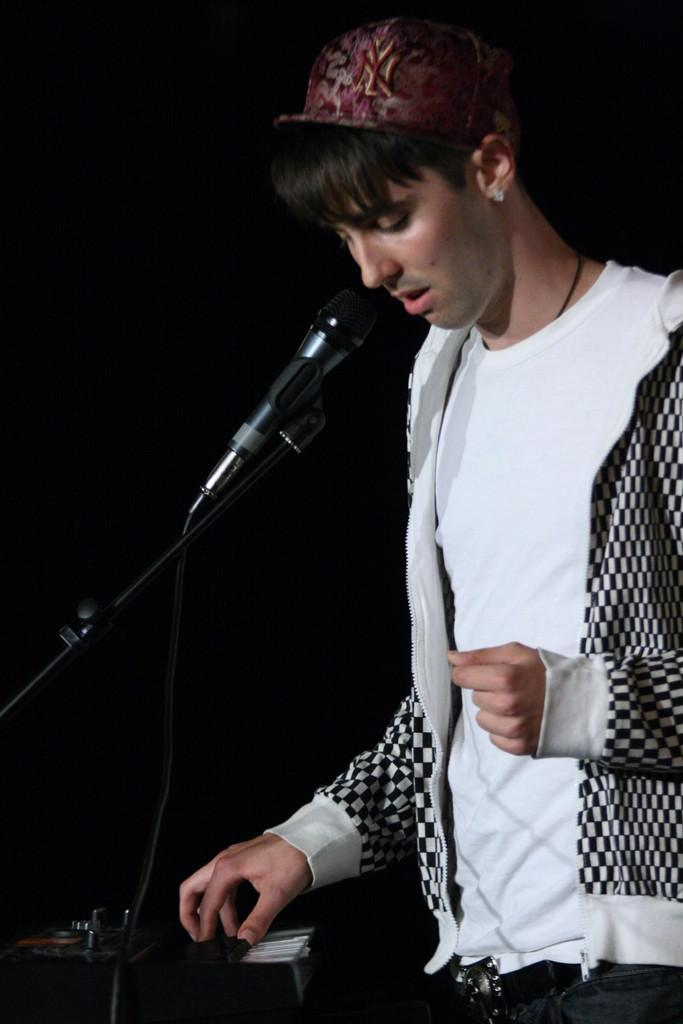What can be seen in the image? There is a person and a mic with a cable in the image. Can you describe the mic in the image? The mic in the image has a cable attached to it. What else is present in the image besides the person and the mic? There is an unspecified object in the image. What committee is meeting in the field in the image? There is no committee or field present in the image. How can someone join the group in the image? There is no group or indication of joining in the image. 